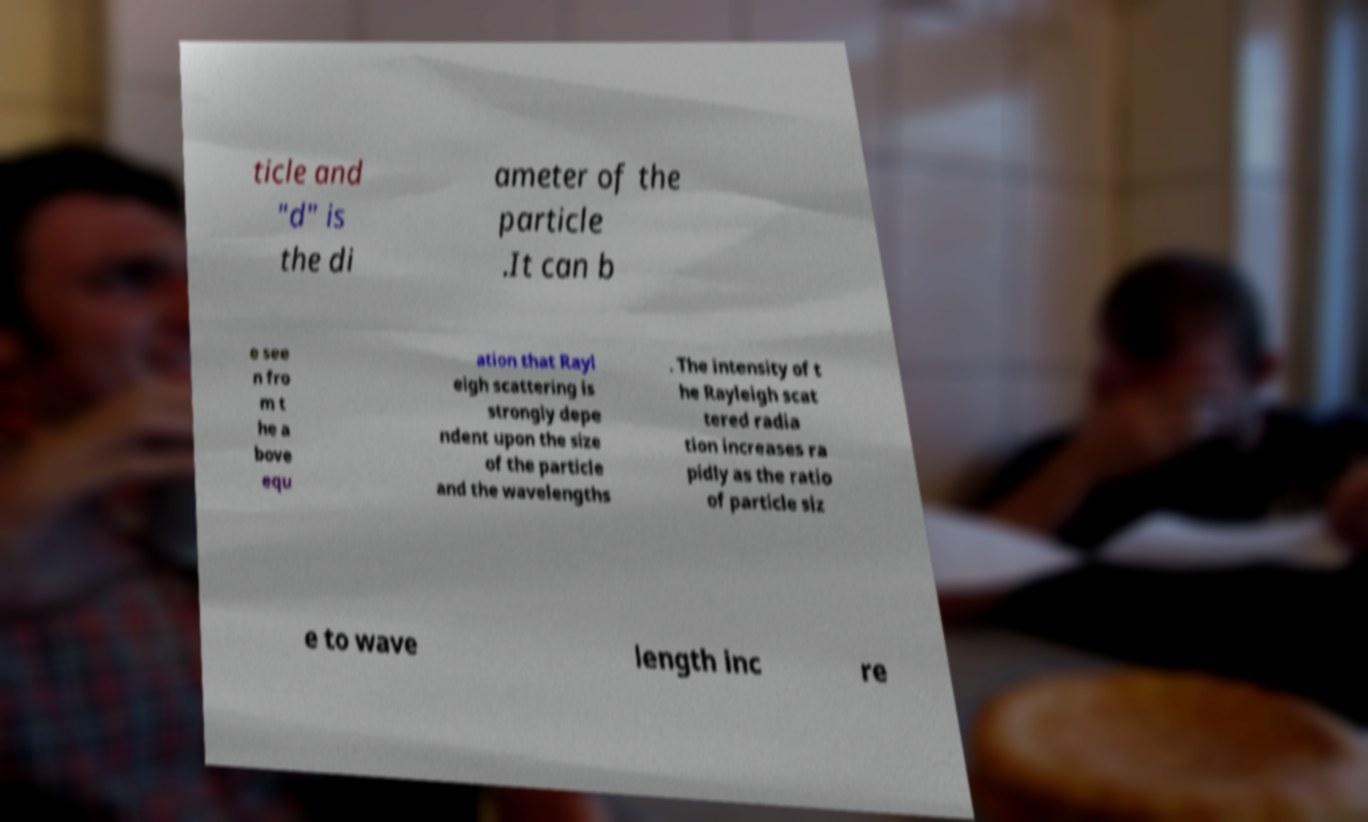Please identify and transcribe the text found in this image. ticle and "d" is the di ameter of the particle .It can b e see n fro m t he a bove equ ation that Rayl eigh scattering is strongly depe ndent upon the size of the particle and the wavelengths . The intensity of t he Rayleigh scat tered radia tion increases ra pidly as the ratio of particle siz e to wave length inc re 